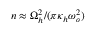<formula> <loc_0><loc_0><loc_500><loc_500>n \approx \Omega _ { h } ^ { 2 } / ( \pi \kappa _ { h } \omega _ { o } ^ { 2 } )</formula> 